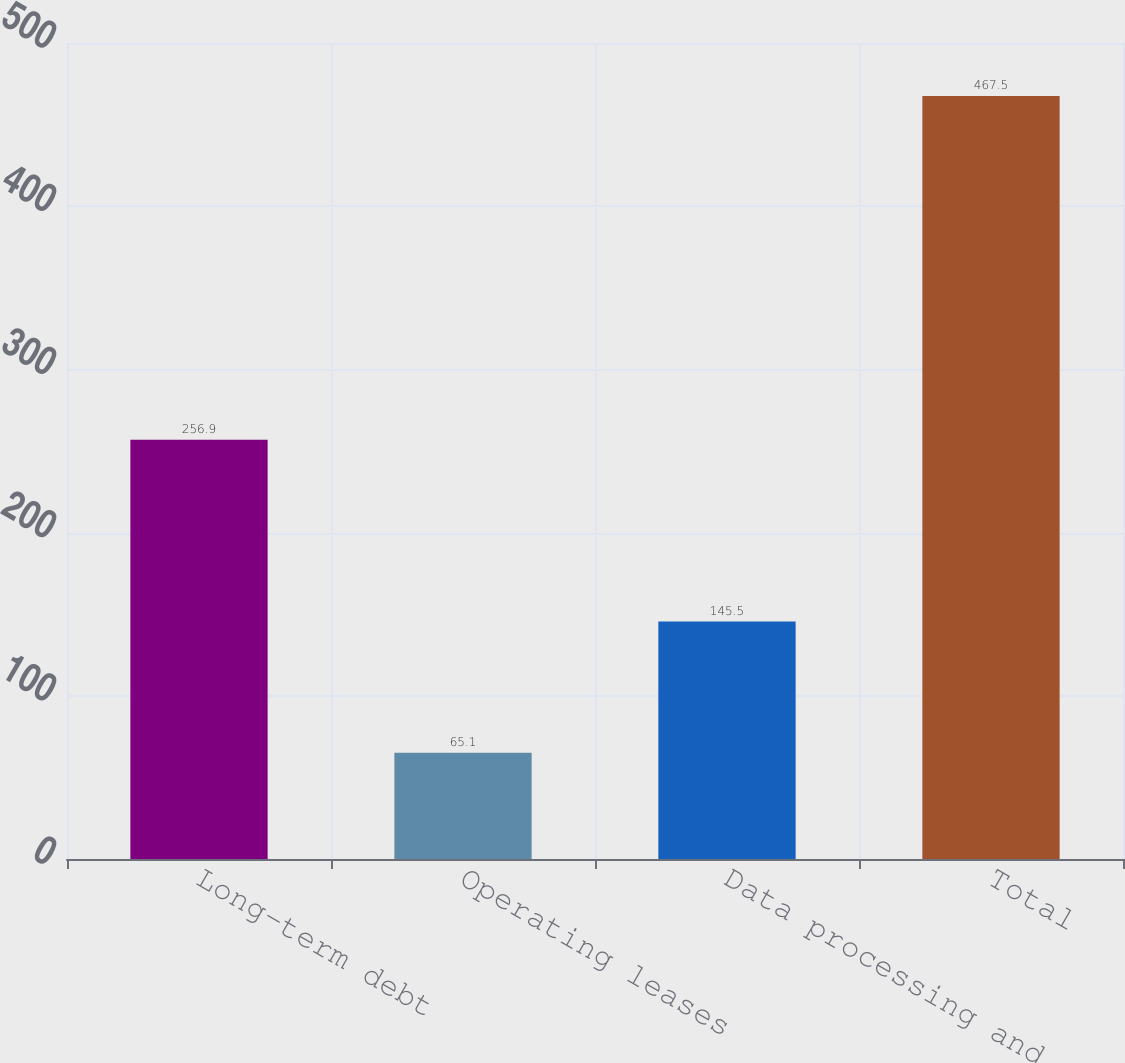<chart> <loc_0><loc_0><loc_500><loc_500><bar_chart><fcel>Long-term debt<fcel>Operating leases<fcel>Data processing and<fcel>Total<nl><fcel>256.9<fcel>65.1<fcel>145.5<fcel>467.5<nl></chart> 